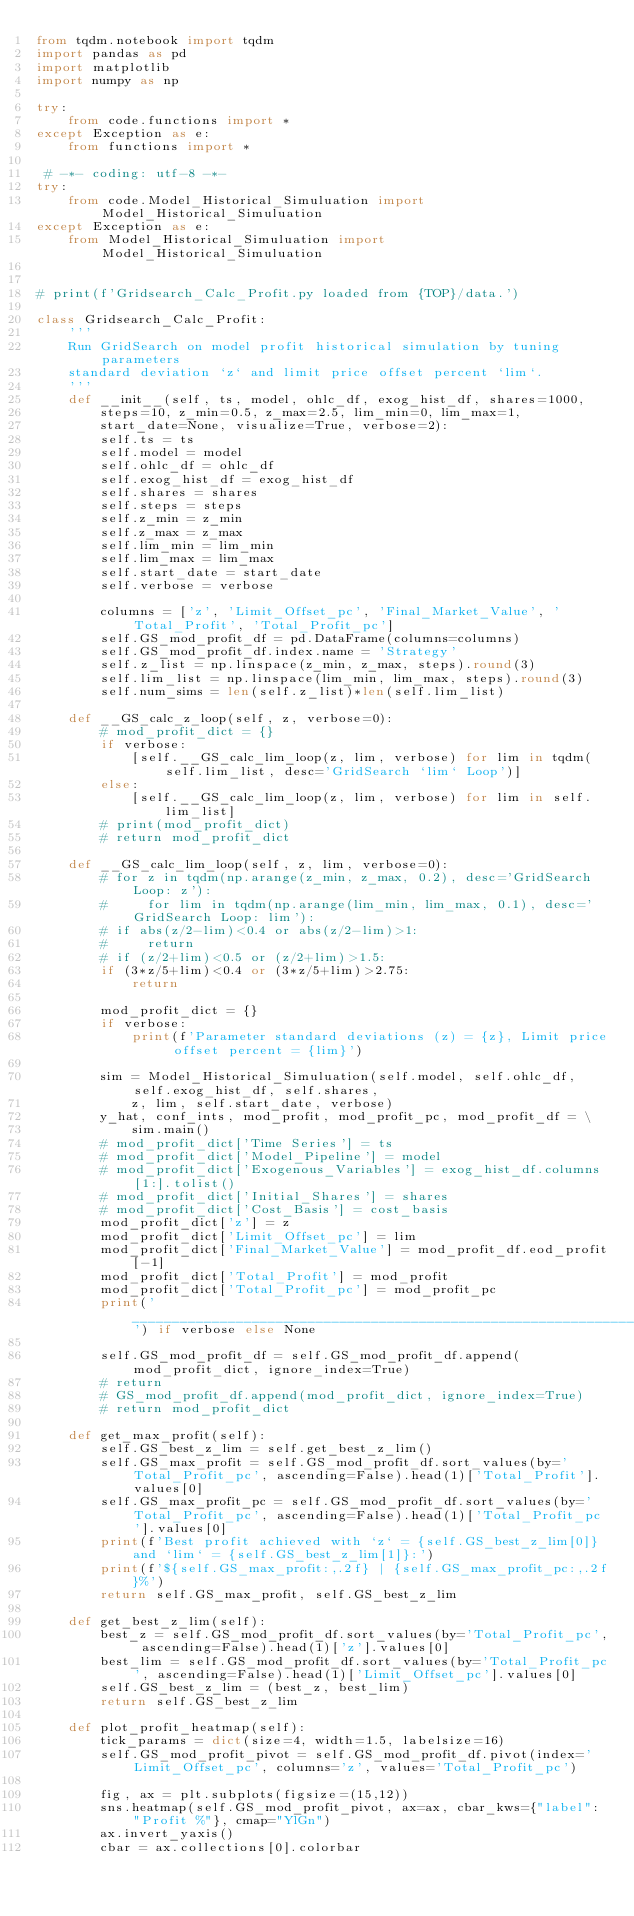Convert code to text. <code><loc_0><loc_0><loc_500><loc_500><_Python_>from tqdm.notebook import tqdm
import pandas as pd
import matplotlib
import numpy as np

try:
    from code.functions import *
except Exception as e:
    from functions import *

 # -*- coding: utf-8 -*-
try:
    from code.Model_Historical_Simuluation import Model_Historical_Simuluation
except Exception as e:
    from Model_Historical_Simuluation import Model_Historical_Simuluation


# print(f'Gridsearch_Calc_Profit.py loaded from {TOP}/data.')

class Gridsearch_Calc_Profit:
    '''
    Run GridSearch on model profit historical simulation by tuning parameters
    standard deviation `z` and limit price offset percent `lim`.
    '''
    def __init__(self, ts, model, ohlc_df, exog_hist_df, shares=1000,
        steps=10, z_min=0.5, z_max=2.5, lim_min=0, lim_max=1,
        start_date=None, visualize=True, verbose=2):
        self.ts = ts
        self.model = model
        self.ohlc_df = ohlc_df
        self.exog_hist_df = exog_hist_df
        self.shares = shares
        self.steps = steps
        self.z_min = z_min
        self.z_max = z_max
        self.lim_min = lim_min
        self.lim_max = lim_max
        self.start_date = start_date
        self.verbose = verbose

        columns = ['z', 'Limit_Offset_pc', 'Final_Market_Value', 'Total_Profit', 'Total_Profit_pc']
        self.GS_mod_profit_df = pd.DataFrame(columns=columns)
        self.GS_mod_profit_df.index.name = 'Strategy'
        self.z_list = np.linspace(z_min, z_max, steps).round(3)
        self.lim_list = np.linspace(lim_min, lim_max, steps).round(3)
        self.num_sims = len(self.z_list)*len(self.lim_list)

    def __GS_calc_z_loop(self, z, verbose=0):
        # mod_profit_dict = {}
        if verbose:
            [self.__GS_calc_lim_loop(z, lim, verbose) for lim in tqdm(self.lim_list, desc='GridSearch `lim` Loop')]
        else:
            [self.__GS_calc_lim_loop(z, lim, verbose) for lim in self.lim_list]
        # print(mod_profit_dict)
        # return mod_profit_dict

    def __GS_calc_lim_loop(self, z, lim, verbose=0):
        # for z in tqdm(np.arange(z_min, z_max, 0.2), desc='GridSearch Loop: z'):
        #     for lim in tqdm(np.arange(lim_min, lim_max, 0.1), desc='GridSearch Loop: lim'):
        # if abs(z/2-lim)<0.4 or abs(z/2-lim)>1:
        #     return
        # if (z/2+lim)<0.5 or (z/2+lim)>1.5:
        if (3*z/5+lim)<0.4 or (3*z/5+lim)>2.75:
            return

        mod_profit_dict = {}
        if verbose:
            print(f'Parameter standard deviations (z) = {z}, Limit price offset percent = {lim}')

        sim = Model_Historical_Simuluation(self.model, self.ohlc_df, self.exog_hist_df, self.shares,
            z, lim, self.start_date, verbose)
        y_hat, conf_ints, mod_profit, mod_profit_pc, mod_profit_df = \
            sim.main()
        # mod_profit_dict['Time Series'] = ts
        # mod_profit_dict['Model_Pipeline'] = model
        # mod_profit_dict['Exogenous_Variables'] = exog_hist_df.columns[1:].tolist()
        # mod_profit_dict['Initial_Shares'] = shares
        # mod_profit_dict['Cost_Basis'] = cost_basis
        mod_profit_dict['z'] = z
        mod_profit_dict['Limit_Offset_pc'] = lim
        mod_profit_dict['Final_Market_Value'] = mod_profit_df.eod_profit[-1]
        mod_profit_dict['Total_Profit'] = mod_profit
        mod_profit_dict['Total_Profit_pc'] = mod_profit_pc
        print('__________________________________________________________________') if verbose else None

        self.GS_mod_profit_df = self.GS_mod_profit_df.append(mod_profit_dict, ignore_index=True)
        # return
        # GS_mod_profit_df.append(mod_profit_dict, ignore_index=True)
        # return mod_profit_dict

    def get_max_profit(self):
        self.GS_best_z_lim = self.get_best_z_lim()
        self.GS_max_profit = self.GS_mod_profit_df.sort_values(by='Total_Profit_pc', ascending=False).head(1)['Total_Profit'].values[0]
        self.GS_max_profit_pc = self.GS_mod_profit_df.sort_values(by='Total_Profit_pc', ascending=False).head(1)['Total_Profit_pc'].values[0]
        print(f'Best profit achieved with `z` = {self.GS_best_z_lim[0]} and `lim` = {self.GS_best_z_lim[1]}:')
        print(f'${self.GS_max_profit:,.2f} | {self.GS_max_profit_pc:,.2f}%')
        return self.GS_max_profit, self.GS_best_z_lim

    def get_best_z_lim(self):
        best_z = self.GS_mod_profit_df.sort_values(by='Total_Profit_pc', ascending=False).head(1)['z'].values[0]
        best_lim = self.GS_mod_profit_df.sort_values(by='Total_Profit_pc', ascending=False).head(1)['Limit_Offset_pc'].values[0]
        self.GS_best_z_lim = (best_z, best_lim)
        return self.GS_best_z_lim

    def plot_profit_heatmap(self):
        tick_params = dict(size=4, width=1.5, labelsize=16)
        self.GS_mod_profit_pivot = self.GS_mod_profit_df.pivot(index='Limit_Offset_pc', columns='z', values='Total_Profit_pc')

        fig, ax = plt.subplots(figsize=(15,12))
        sns.heatmap(self.GS_mod_profit_pivot, ax=ax, cbar_kws={"label": "Profit %"}, cmap="YlGn")
        ax.invert_yaxis()
        cbar = ax.collections[0].colorbar</code> 